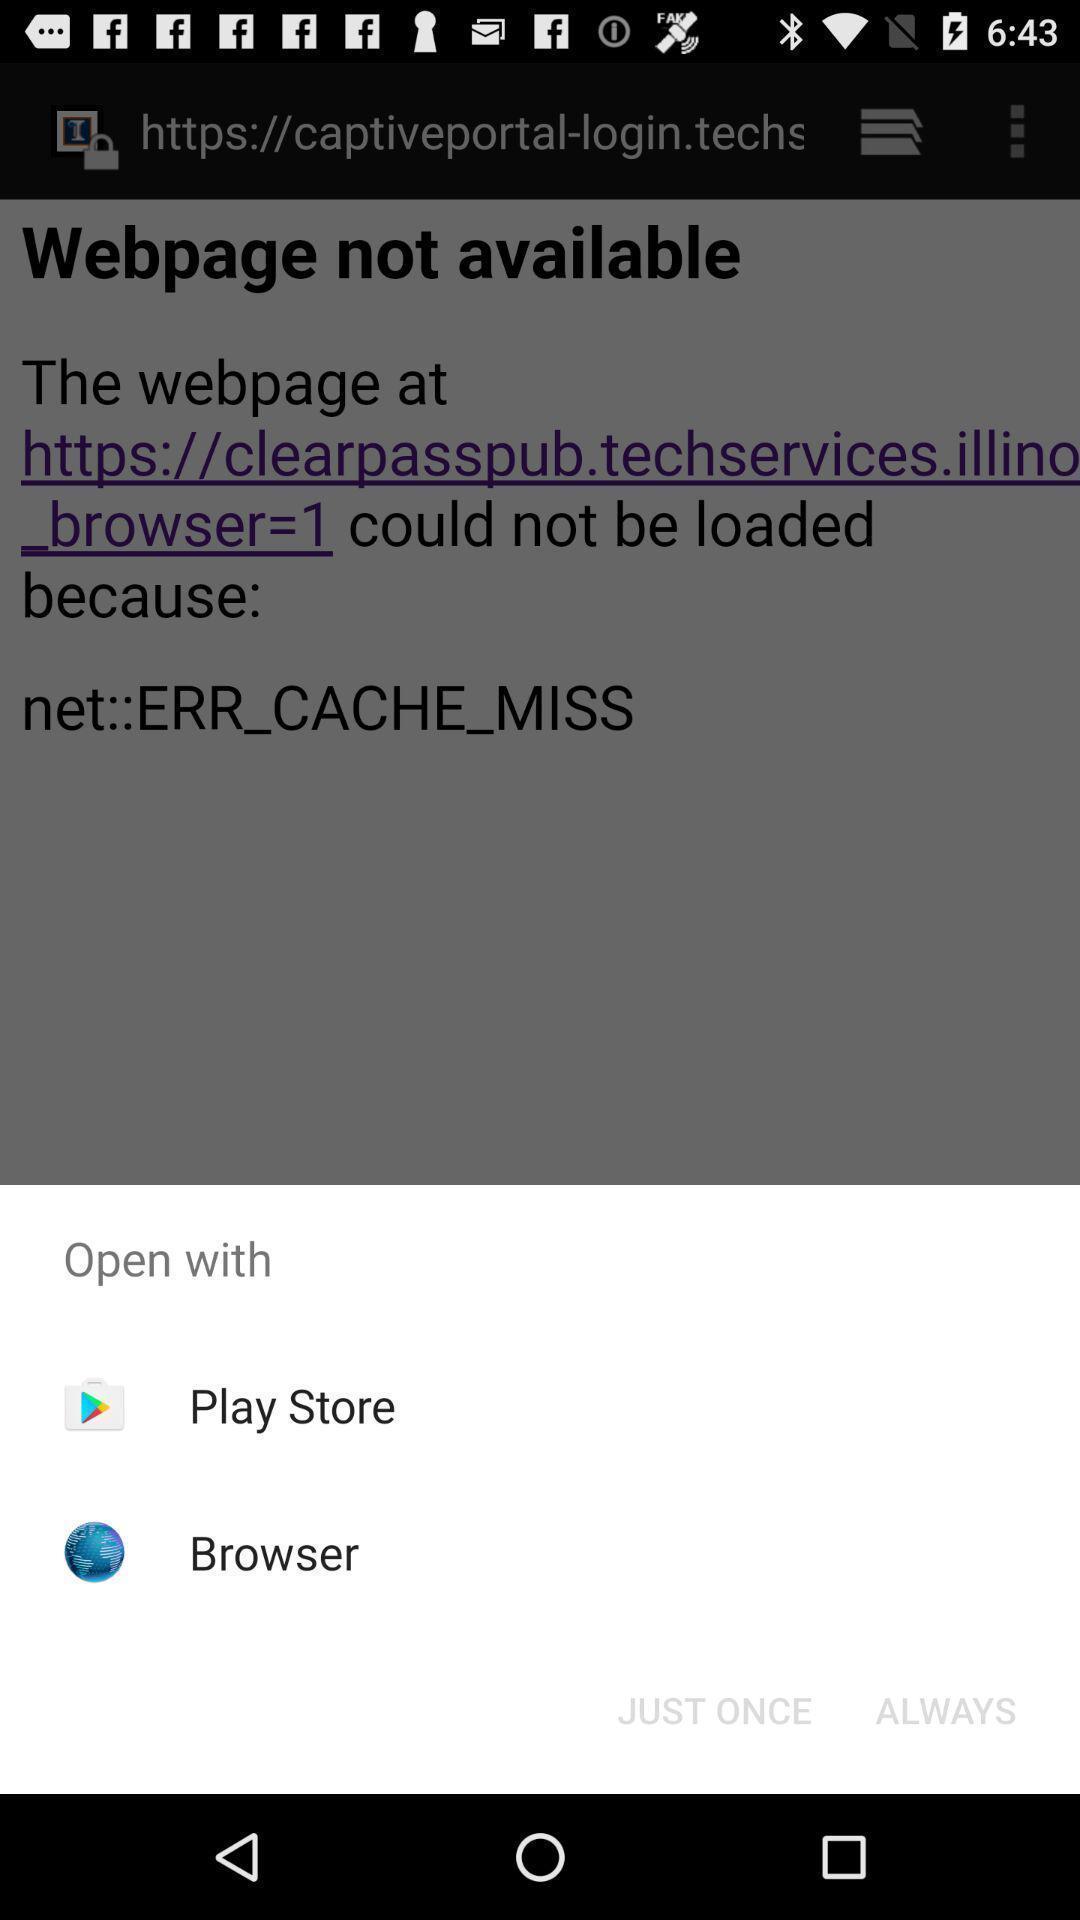Tell me what you see in this picture. Web page open with different apps. 